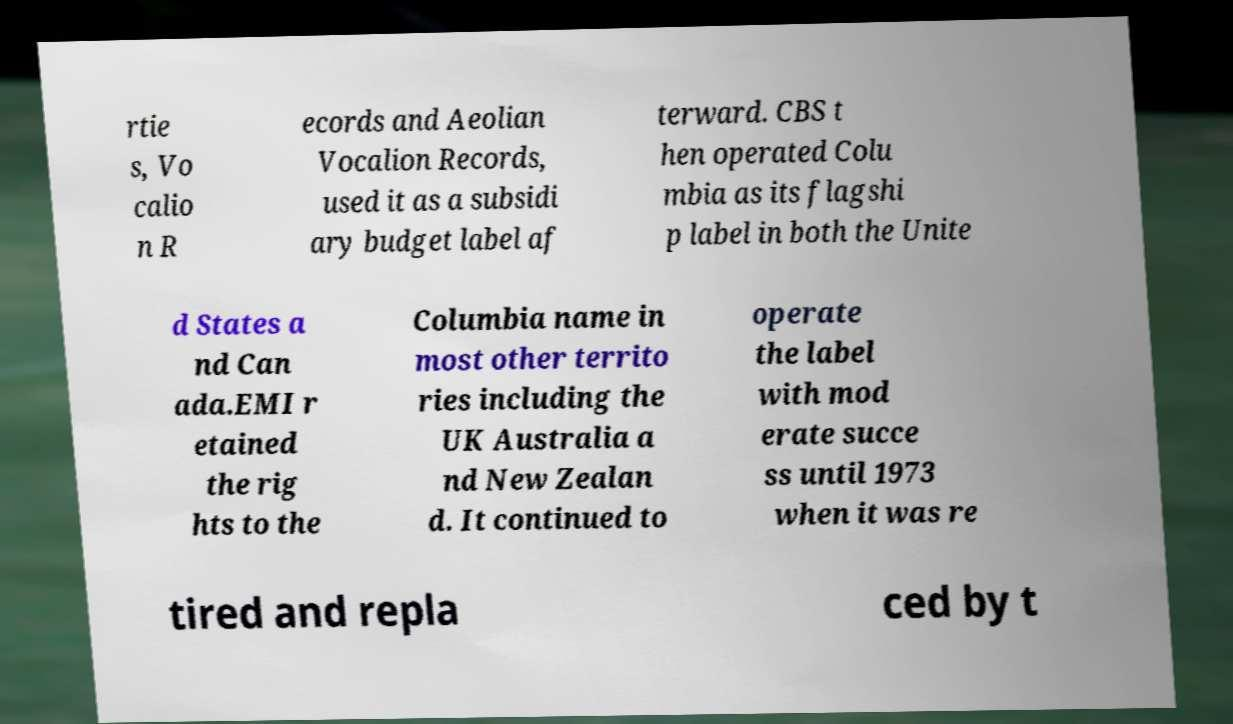There's text embedded in this image that I need extracted. Can you transcribe it verbatim? rtie s, Vo calio n R ecords and Aeolian Vocalion Records, used it as a subsidi ary budget label af terward. CBS t hen operated Colu mbia as its flagshi p label in both the Unite d States a nd Can ada.EMI r etained the rig hts to the Columbia name in most other territo ries including the UK Australia a nd New Zealan d. It continued to operate the label with mod erate succe ss until 1973 when it was re tired and repla ced by t 